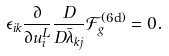Convert formula to latex. <formula><loc_0><loc_0><loc_500><loc_500>\epsilon _ { i k } \frac { \partial } { \partial u _ { i } ^ { L } } \frac { D } { D \bar { \lambda } _ { k j } } \mathcal { F } _ { g } ^ { ( \text {6d} ) } = 0 .</formula> 